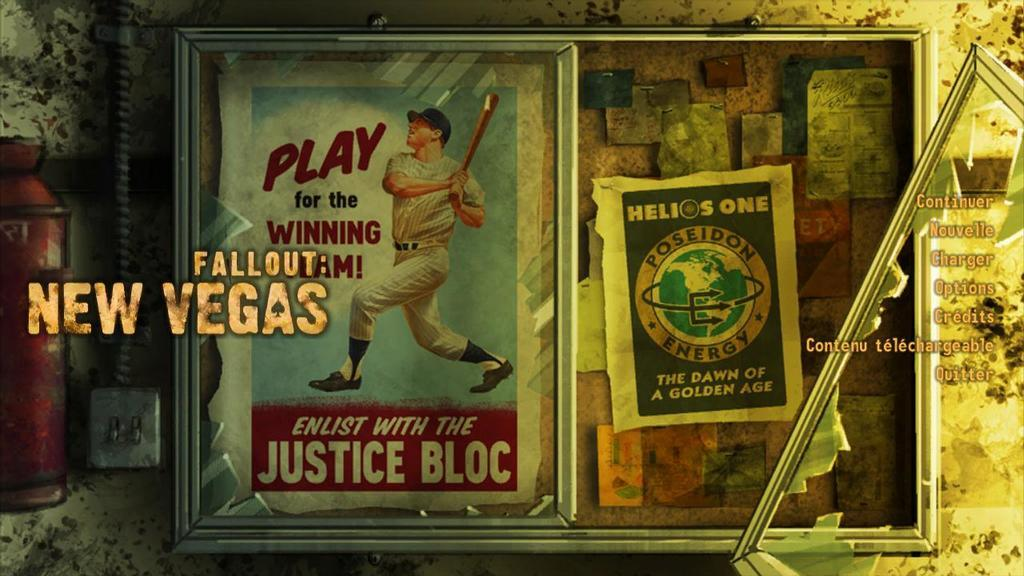Provide a one-sentence caption for the provided image. An advertisement to Play for the Winning Team, Enlist with the Justice Bloc. 